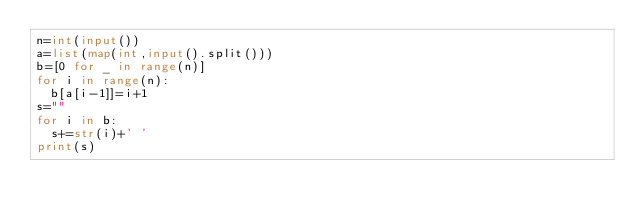Convert code to text. <code><loc_0><loc_0><loc_500><loc_500><_Python_>n=int(input())
a=list(map(int,input().split()))
b=[0 for _ in range(n)]
for i in range(n):
  b[a[i-1]]=i+1
s=""
for i in b:
  s+=str(i)+' '
print(s)</code> 